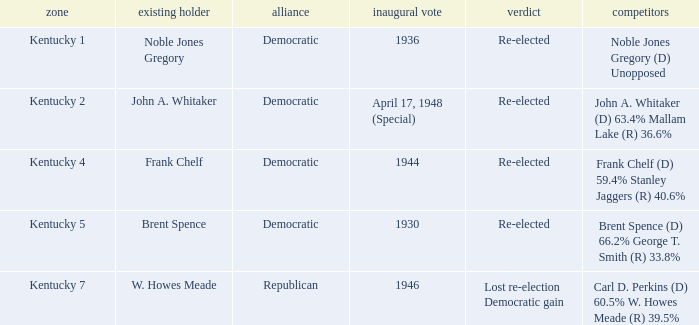Which party won in the election in voting district Kentucky 5? Democratic. 